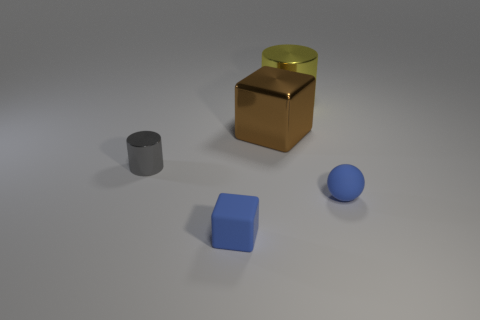There is a cube that is made of the same material as the yellow object; what is its color?
Your response must be concise. Brown. Are there any gray metallic cylinders behind the metallic cylinder in front of the large brown metal object?
Your response must be concise. No. What number of other things are there of the same shape as the yellow object?
Your answer should be compact. 1. Does the blue matte object that is behind the small rubber cube have the same shape as the large object that is right of the large brown block?
Provide a short and direct response. No. There is a big yellow cylinder behind the matte object on the left side of the tiny sphere; how many brown shiny things are on the left side of it?
Your answer should be very brief. 1. The small block has what color?
Your response must be concise. Blue. How many other objects are the same size as the gray cylinder?
Offer a very short reply. 2. There is a tiny gray thing that is the same shape as the yellow thing; what is its material?
Keep it short and to the point. Metal. The object that is in front of the tiny rubber thing to the right of the small blue thing that is left of the rubber ball is made of what material?
Make the answer very short. Rubber. There is a gray cylinder that is made of the same material as the yellow thing; what size is it?
Your response must be concise. Small. 